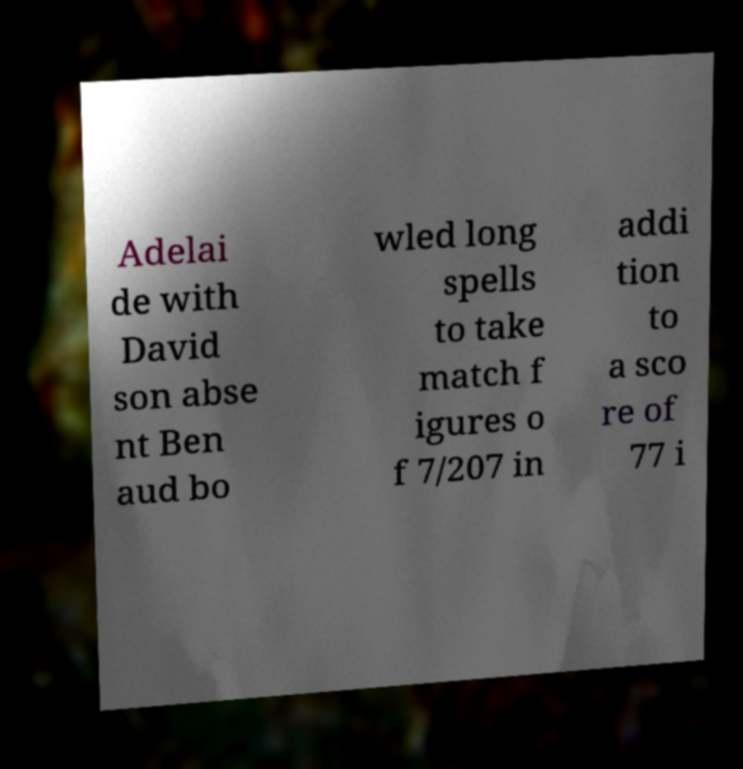There's text embedded in this image that I need extracted. Can you transcribe it verbatim? Adelai de with David son abse nt Ben aud bo wled long spells to take match f igures o f 7/207 in addi tion to a sco re of 77 i 